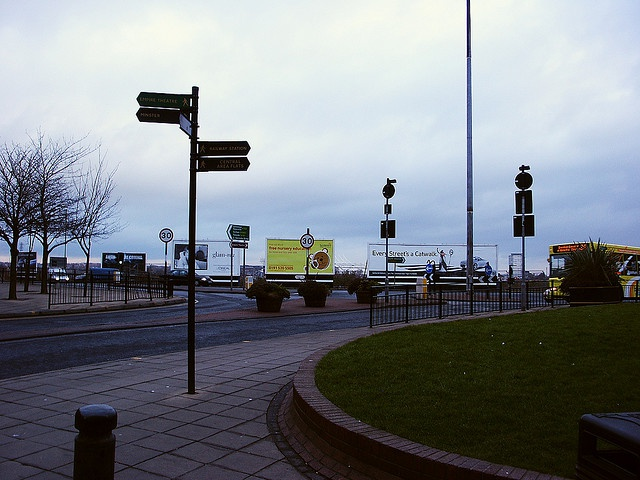Describe the objects in this image and their specific colors. I can see bus in lavender, black, olive, maroon, and gray tones, car in lavender, black, navy, gray, and darkblue tones, car in lavender, black, navy, and gray tones, car in lavender, black, navy, and blue tones, and car in lavender, black, gray, and navy tones in this image. 